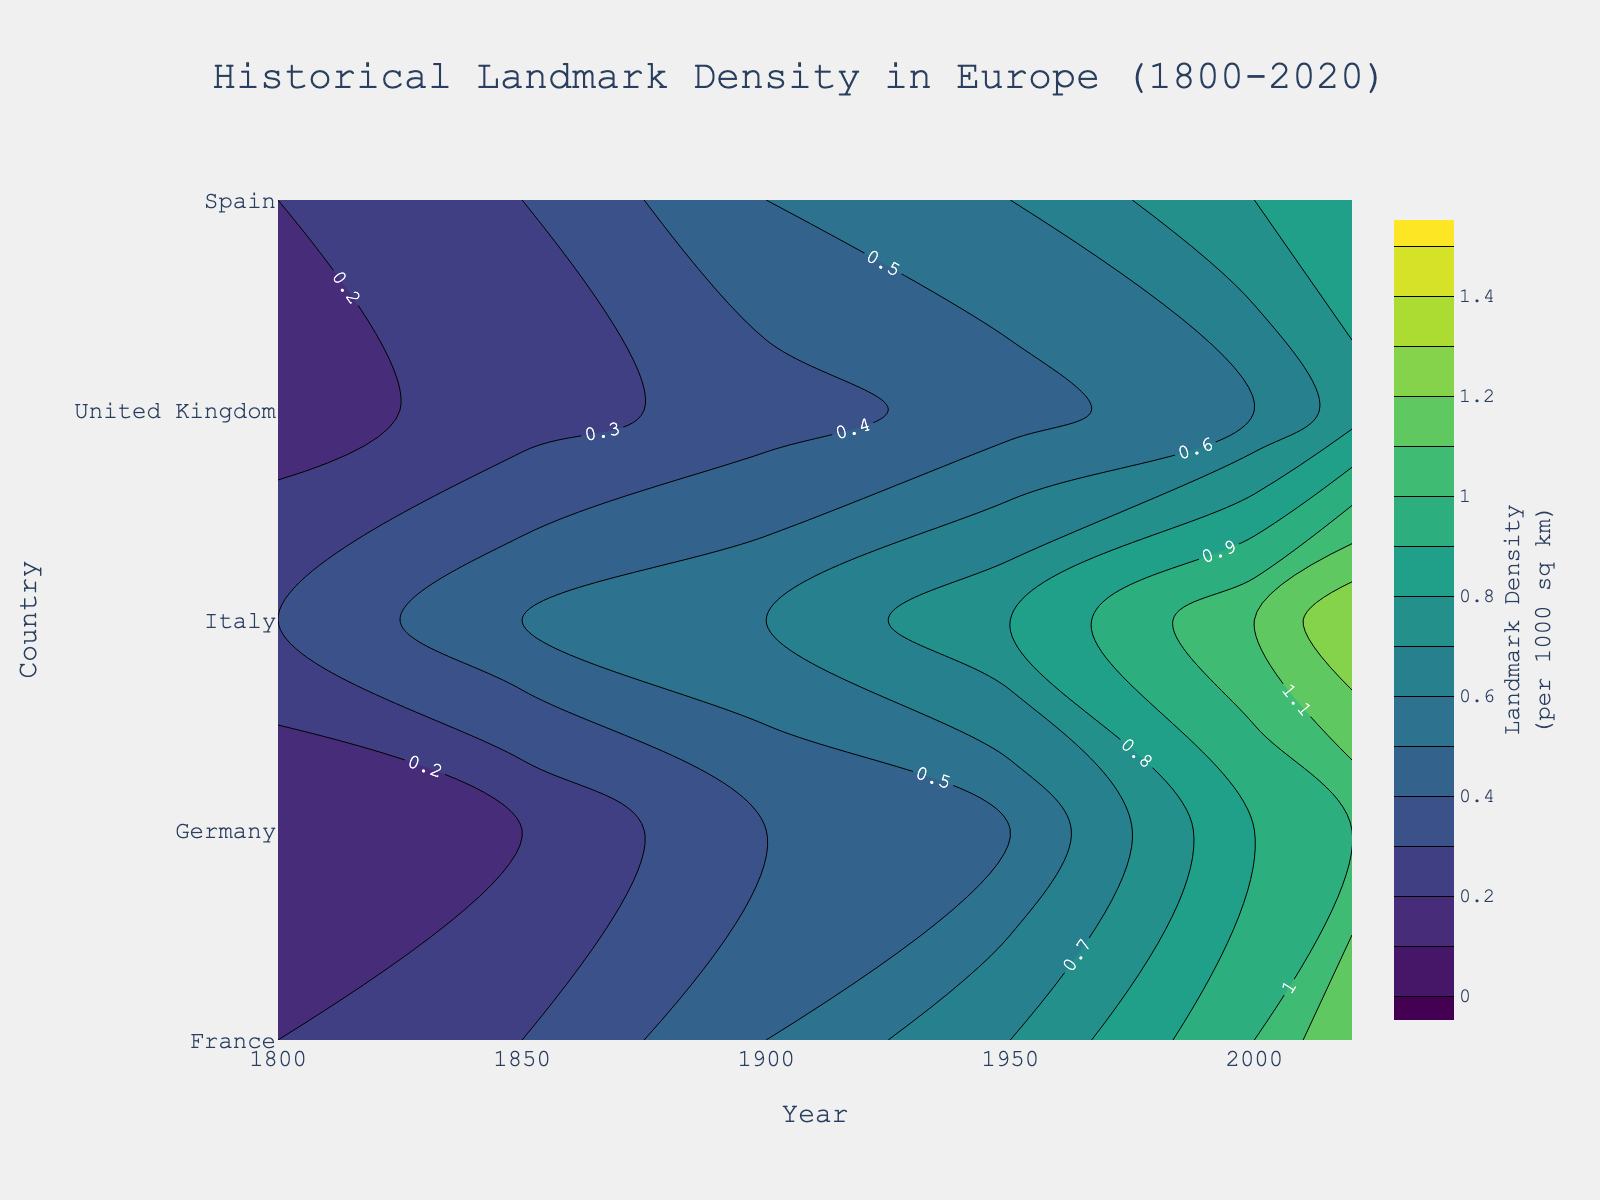What is the title of the figure? The title is typically found at the top of the figure. In this case, it clearly reads "Historical Landmark Density in Europe (1800-2020)".
Answer: Historical Landmark Density in Europe (1800-2020) What are the x-axis and y-axis representing? The x-axis represents the "Year", and the y-axis represents the "Country". This information is usually found along the axis labels.
Answer: Year; Country Which country had the highest landmark density in 2020? From the contour lines and the color gradient, Italy shows the highest landmark density in 2020.
Answer: Italy Based on the contour plot, which country shows a continuous increasing trend in landmark density from 1800 to 2020? Observing the progression of the contour lines over time for each country, Italy shows a continuous increasing trend in landmark density over the years from 1800 to 2020.
Answer: Italy How does the landmark density of Germany in 1950 compare with that of France in 1850? By looking at the contour levels corresponding to the years and countries, Germany's density in 1950 is around 0.5, while France’s in 1850 is around 0.3. So Germany's density in 1950 is higher.
Answer: Germany's density is higher Which country had the lowest increase in landmark density from 1800 to 2020? By comparing the change in contour levels for each country from 1800 to 2020, Spain had the lowest increase in landmark density, increasing from 0.15 to 0.75.
Answer: Spain What is the overall range of landmark density values shown in the contour plot? The overall range can be observed from the color legend which indicates it starts from 0 to 1.5 landmarks per 1000 sq km.
Answer: 0 to 1.5 Comparing France and Germany in 2020, which country had a higher landmark density and by how much? The contour lines and color indicate France had a density of 1.2 and Germany had 1.0 in 2020. The difference is 1.2 - 1.0 = 0.2.
Answer: France by 0.2 Around which year did Italy's landmark density surpass 1.0 per 1000 sq km? Follow the contour lines corresponding to Italy; the density crosses 1.0 around the year 2000.
Answer: Around 2000 Is there any country that had no significant increase in landmark density between 1800 and 1900? By observing the contour plot for the period between 1800 and 1900, Germany had no significant increase (from 0.1 to 0.4).
Answer: Germany 